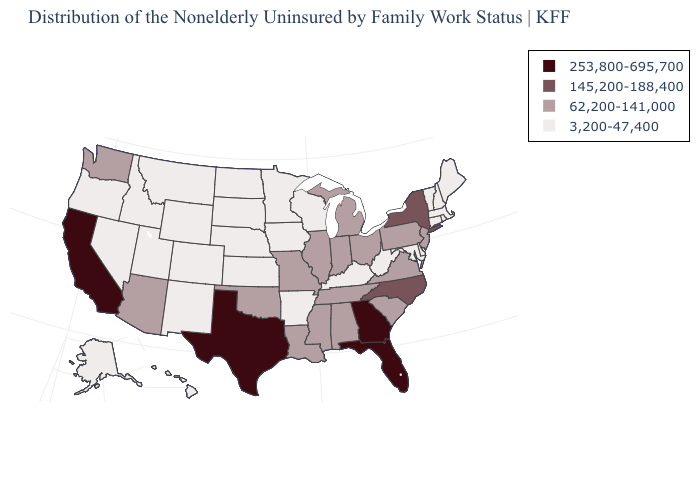What is the value of Massachusetts?
Be succinct. 3,200-47,400. Name the states that have a value in the range 3,200-47,400?
Give a very brief answer. Alaska, Arkansas, Colorado, Connecticut, Delaware, Hawaii, Idaho, Iowa, Kansas, Kentucky, Maine, Maryland, Massachusetts, Minnesota, Montana, Nebraska, Nevada, New Hampshire, New Mexico, North Dakota, Oregon, Rhode Island, South Dakota, Utah, Vermont, West Virginia, Wisconsin, Wyoming. Among the states that border Utah , does Nevada have the lowest value?
Be succinct. Yes. Name the states that have a value in the range 145,200-188,400?
Quick response, please. New York, North Carolina. Name the states that have a value in the range 145,200-188,400?
Be succinct. New York, North Carolina. Name the states that have a value in the range 62,200-141,000?
Be succinct. Alabama, Arizona, Illinois, Indiana, Louisiana, Michigan, Mississippi, Missouri, New Jersey, Ohio, Oklahoma, Pennsylvania, South Carolina, Tennessee, Virginia, Washington. Does the first symbol in the legend represent the smallest category?
Quick response, please. No. What is the value of California?
Keep it brief. 253,800-695,700. How many symbols are there in the legend?
Write a very short answer. 4. What is the highest value in states that border Florida?
Concise answer only. 253,800-695,700. What is the highest value in states that border Colorado?
Give a very brief answer. 62,200-141,000. Name the states that have a value in the range 62,200-141,000?
Concise answer only. Alabama, Arizona, Illinois, Indiana, Louisiana, Michigan, Mississippi, Missouri, New Jersey, Ohio, Oklahoma, Pennsylvania, South Carolina, Tennessee, Virginia, Washington. How many symbols are there in the legend?
Short answer required. 4. What is the value of North Carolina?
Quick response, please. 145,200-188,400. What is the value of Maryland?
Write a very short answer. 3,200-47,400. 